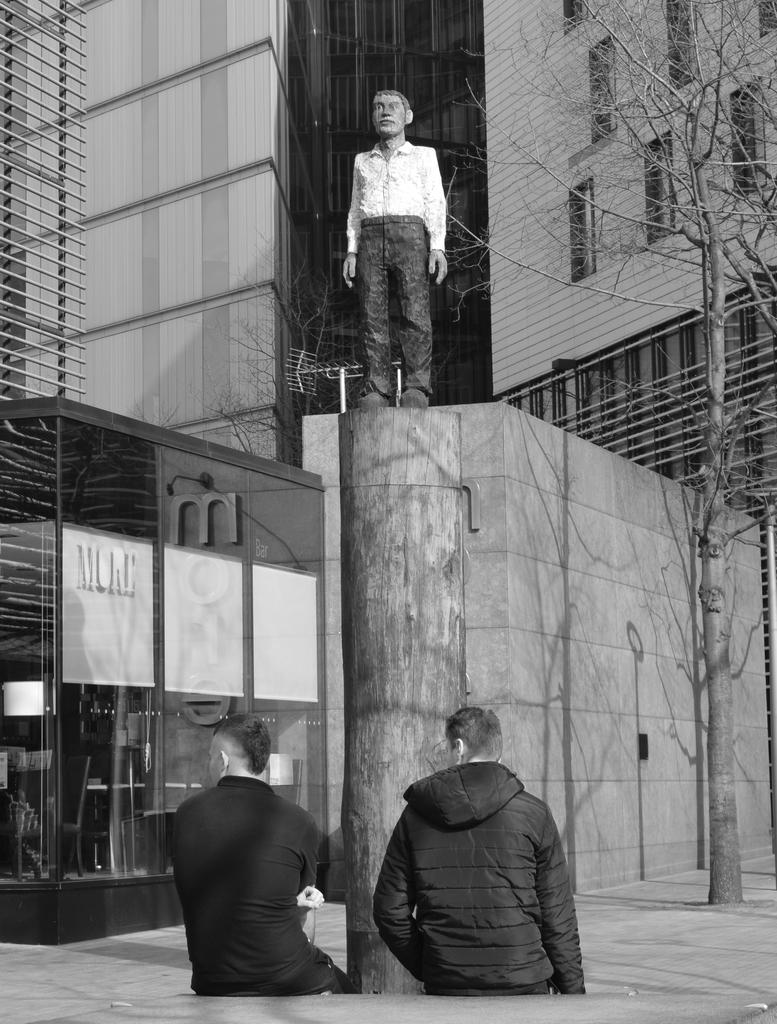How many people are present in the image? There are two people in the image. What can be seen on the pole in the image? There is a statue on the pole in the image. What type of structures can be seen in the background of the image? There are buildings and walls visible in the background of the image. What material is present in the background of the image? There is glass and trees visible in the background of the image. What is at the bottom of the image? There is a walkway at the bottom of the image. How many brothers are depicted in the image? There is no information about brothers in the image, as it only shows two people. What type of territory is being claimed by the statue in the image? There is no indication of territory being claimed in the image; it simply features a statue on a pole. 